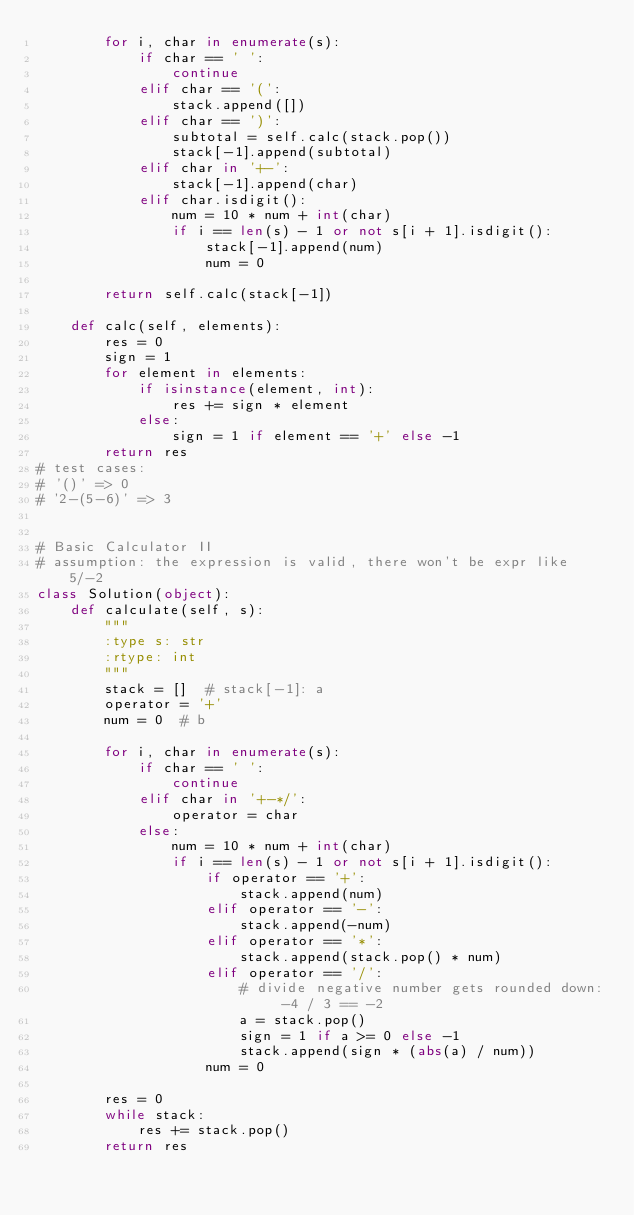<code> <loc_0><loc_0><loc_500><loc_500><_Python_>        for i, char in enumerate(s):
            if char == ' ':
                continue
            elif char == '(':
                stack.append([])
            elif char == ')':
                subtotal = self.calc(stack.pop())
                stack[-1].append(subtotal)
            elif char in '+-':
                stack[-1].append(char)
            elif char.isdigit():
                num = 10 * num + int(char)
                if i == len(s) - 1 or not s[i + 1].isdigit():
                    stack[-1].append(num)
                    num = 0

        return self.calc(stack[-1])

    def calc(self, elements):
        res = 0
        sign = 1
        for element in elements:
            if isinstance(element, int):
                res += sign * element
            else:
                sign = 1 if element == '+' else -1
        return res
# test cases:
# '()' => 0
# '2-(5-6)' => 3


# Basic Calculator II
# assumption: the expression is valid, there won't be expr like 5/-2
class Solution(object):
    def calculate(self, s):
        """
        :type s: str
        :rtype: int
        """
        stack = []  # stack[-1]: a
        operator = '+'
        num = 0  # b

        for i, char in enumerate(s):
            if char == ' ':
                continue
            elif char in '+-*/':
                operator = char
            else:
                num = 10 * num + int(char)
                if i == len(s) - 1 or not s[i + 1].isdigit():
                    if operator == '+':
                        stack.append(num)
                    elif operator == '-':
                        stack.append(-num)
                    elif operator == '*':
                        stack.append(stack.pop() * num)
                    elif operator == '/':
                        # divide negative number gets rounded down: -4 / 3 == -2
                        a = stack.pop()
                        sign = 1 if a >= 0 else -1
                        stack.append(sign * (abs(a) / num))
                    num = 0

        res = 0
        while stack:
            res += stack.pop()
        return res
</code> 